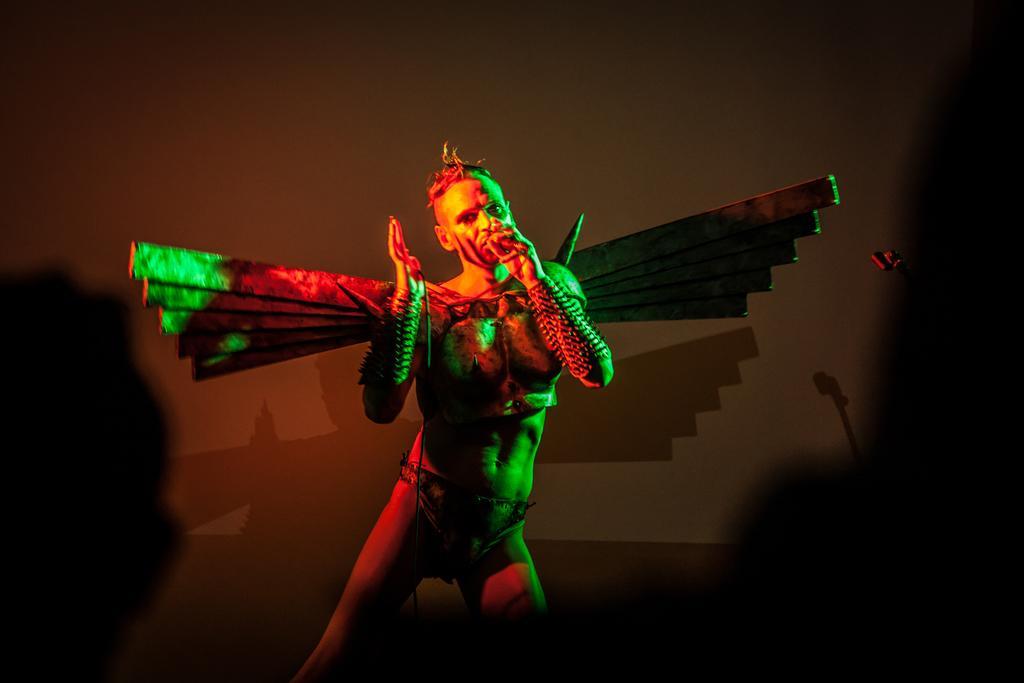How would you summarize this image in a sentence or two? In this image we can see this person is wearing a different costume. The background of the image is dark. 